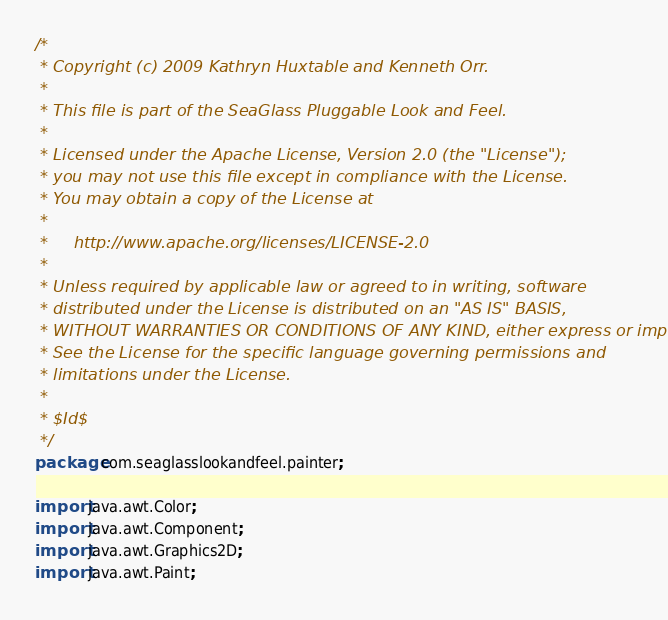<code> <loc_0><loc_0><loc_500><loc_500><_Java_>/*
 * Copyright (c) 2009 Kathryn Huxtable and Kenneth Orr.
 *
 * This file is part of the SeaGlass Pluggable Look and Feel.
 *
 * Licensed under the Apache License, Version 2.0 (the "License");
 * you may not use this file except in compliance with the License.
 * You may obtain a copy of the License at
 *
 *     http://www.apache.org/licenses/LICENSE-2.0
 *
 * Unless required by applicable law or agreed to in writing, software
 * distributed under the License is distributed on an "AS IS" BASIS,
 * WITHOUT WARRANTIES OR CONDITIONS OF ANY KIND, either express or implied.
 * See the License for the specific language governing permissions and
 * limitations under the License.
 *
 * $Id$
 */
package com.seaglasslookandfeel.painter;

import java.awt.Color;
import java.awt.Component;
import java.awt.Graphics2D;
import java.awt.Paint;</code> 